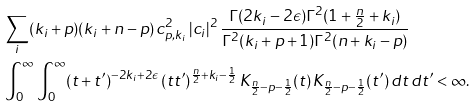Convert formula to latex. <formula><loc_0><loc_0><loc_500><loc_500>& \sum _ { i } ( k _ { i } + p ) ( k _ { i } + n - p ) \, c _ { p , k _ { i } } ^ { 2 } \, | c _ { i } | ^ { 2 } \, \frac { \Gamma ( 2 k _ { i } - 2 \epsilon ) \Gamma ^ { 2 } ( 1 + \frac { n } { 2 } + k _ { i } ) } { \Gamma ^ { 2 } ( k _ { i } + p + 1 ) \Gamma ^ { 2 } ( n + k _ { i } - p ) } \\ & \int _ { 0 } ^ { \infty } \int _ { 0 } ^ { \infty } ( t + t ^ { \prime } ) ^ { - 2 k _ { i } + 2 \epsilon } \, ( t t ^ { \prime } ) ^ { \frac { n } { 2 } + k _ { i } - \frac { 1 } { 2 } } \, K _ { \frac { n } { 2 } - p - \frac { 1 } { 2 } } ( t ) \, K _ { \frac { n } { 2 } - p - \frac { 1 } { 2 } } ( t ^ { \prime } ) \, d t \, d t ^ { \prime } < \infty .</formula> 